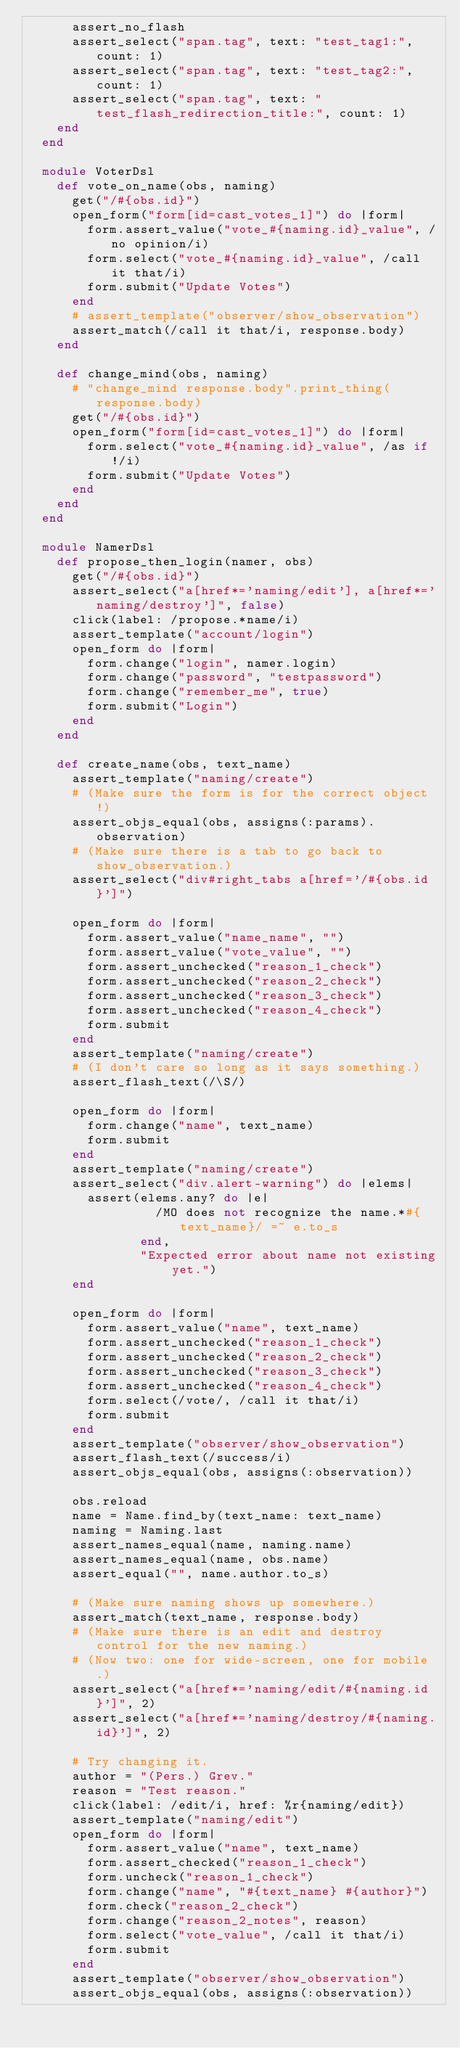<code> <loc_0><loc_0><loc_500><loc_500><_Ruby_>      assert_no_flash
      assert_select("span.tag", text: "test_tag1:", count: 1)
      assert_select("span.tag", text: "test_tag2:", count: 1)
      assert_select("span.tag", text: "test_flash_redirection_title:", count: 1)
    end
  end

  module VoterDsl
    def vote_on_name(obs, naming)
      get("/#{obs.id}")
      open_form("form[id=cast_votes_1]") do |form|
        form.assert_value("vote_#{naming.id}_value", /no opinion/i)
        form.select("vote_#{naming.id}_value", /call it that/i)
        form.submit("Update Votes")
      end
      # assert_template("observer/show_observation")
      assert_match(/call it that/i, response.body)
    end

    def change_mind(obs, naming)
      # "change_mind response.body".print_thing(response.body)
      get("/#{obs.id}")
      open_form("form[id=cast_votes_1]") do |form|
        form.select("vote_#{naming.id}_value", /as if!/i)
        form.submit("Update Votes")
      end
    end
  end

  module NamerDsl
    def propose_then_login(namer, obs)
      get("/#{obs.id}")
      assert_select("a[href*='naming/edit'], a[href*='naming/destroy']", false)
      click(label: /propose.*name/i)
      assert_template("account/login")
      open_form do |form|
        form.change("login", namer.login)
        form.change("password", "testpassword")
        form.change("remember_me", true)
        form.submit("Login")
      end
    end

    def create_name(obs, text_name)
      assert_template("naming/create")
      # (Make sure the form is for the correct object!)
      assert_objs_equal(obs, assigns(:params).observation)
      # (Make sure there is a tab to go back to show_observation.)
      assert_select("div#right_tabs a[href='/#{obs.id}']")

      open_form do |form|
        form.assert_value("name_name", "")
        form.assert_value("vote_value", "")
        form.assert_unchecked("reason_1_check")
        form.assert_unchecked("reason_2_check")
        form.assert_unchecked("reason_3_check")
        form.assert_unchecked("reason_4_check")
        form.submit
      end
      assert_template("naming/create")
      # (I don't care so long as it says something.)
      assert_flash_text(/\S/)

      open_form do |form|
        form.change("name", text_name)
        form.submit
      end
      assert_template("naming/create")
      assert_select("div.alert-warning") do |elems|
        assert(elems.any? do |e|
                 /MO does not recognize the name.*#{text_name}/ =~ e.to_s
               end,
               "Expected error about name not existing yet.")
      end

      open_form do |form|
        form.assert_value("name", text_name)
        form.assert_unchecked("reason_1_check")
        form.assert_unchecked("reason_2_check")
        form.assert_unchecked("reason_3_check")
        form.assert_unchecked("reason_4_check")
        form.select(/vote/, /call it that/i)
        form.submit
      end
      assert_template("observer/show_observation")
      assert_flash_text(/success/i)
      assert_objs_equal(obs, assigns(:observation))

      obs.reload
      name = Name.find_by(text_name: text_name)
      naming = Naming.last
      assert_names_equal(name, naming.name)
      assert_names_equal(name, obs.name)
      assert_equal("", name.author.to_s)

      # (Make sure naming shows up somewhere.)
      assert_match(text_name, response.body)
      # (Make sure there is an edit and destroy control for the new naming.)
      # (Now two: one for wide-screen, one for mobile.)
      assert_select("a[href*='naming/edit/#{naming.id}']", 2)
      assert_select("a[href*='naming/destroy/#{naming.id}']", 2)

      # Try changing it.
      author = "(Pers.) Grev."
      reason = "Test reason."
      click(label: /edit/i, href: %r{naming/edit})
      assert_template("naming/edit")
      open_form do |form|
        form.assert_value("name", text_name)
        form.assert_checked("reason_1_check")
        form.uncheck("reason_1_check")
        form.change("name", "#{text_name} #{author}")
        form.check("reason_2_check")
        form.change("reason_2_notes", reason)
        form.select("vote_value", /call it that/i)
        form.submit
      end
      assert_template("observer/show_observation")
      assert_objs_equal(obs, assigns(:observation))
</code> 